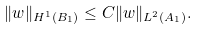Convert formula to latex. <formula><loc_0><loc_0><loc_500><loc_500>\| w \| _ { H ^ { 1 } ( B _ { 1 } ) } \leq C \| w \| _ { L ^ { 2 } ( A _ { 1 } ) } .</formula> 